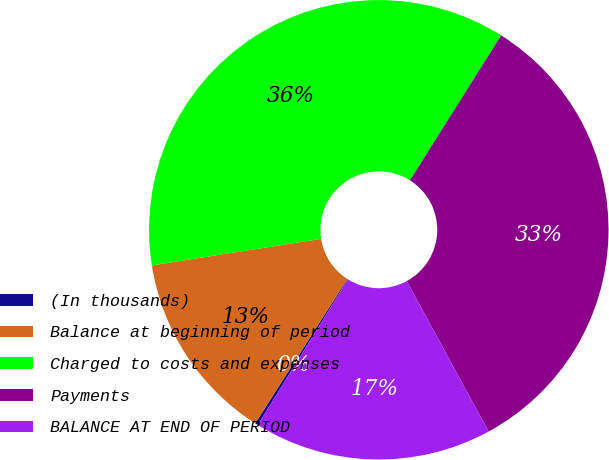Convert chart to OTSL. <chart><loc_0><loc_0><loc_500><loc_500><pie_chart><fcel>(In thousands)<fcel>Balance at beginning of period<fcel>Charged to costs and expenses<fcel>Payments<fcel>BALANCE AT END OF PERIOD<nl><fcel>0.21%<fcel>13.48%<fcel>36.42%<fcel>33.13%<fcel>16.77%<nl></chart> 